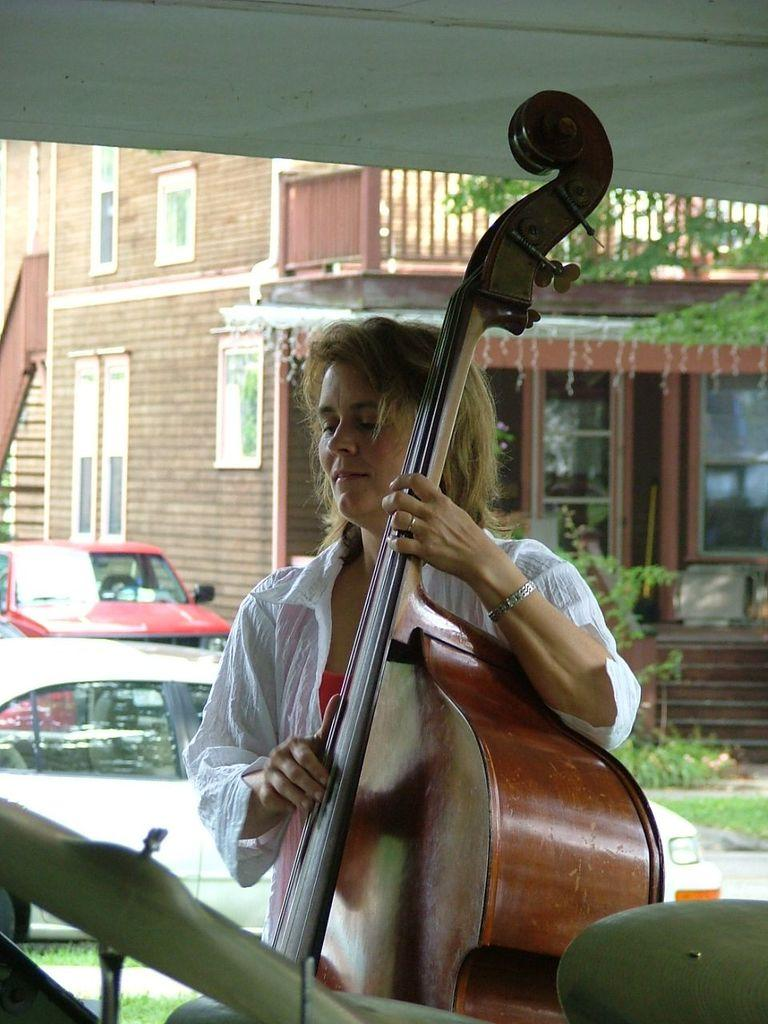Who is the main subject in the image? There is a lady in the image. What is the lady holding in the image? The lady is holding a musical instrument. What can be seen in the background of the image? There is a building with windows in the background of the image. Are there any vehicles visible in the image? Yes, there are cars visible in the image. Where is the pail located in the image? There is no pail present in the image. What is the lady thinking about while holding the musical instrument? The image does not provide information about the lady's thoughts or intentions, so we cannot answer this question. 